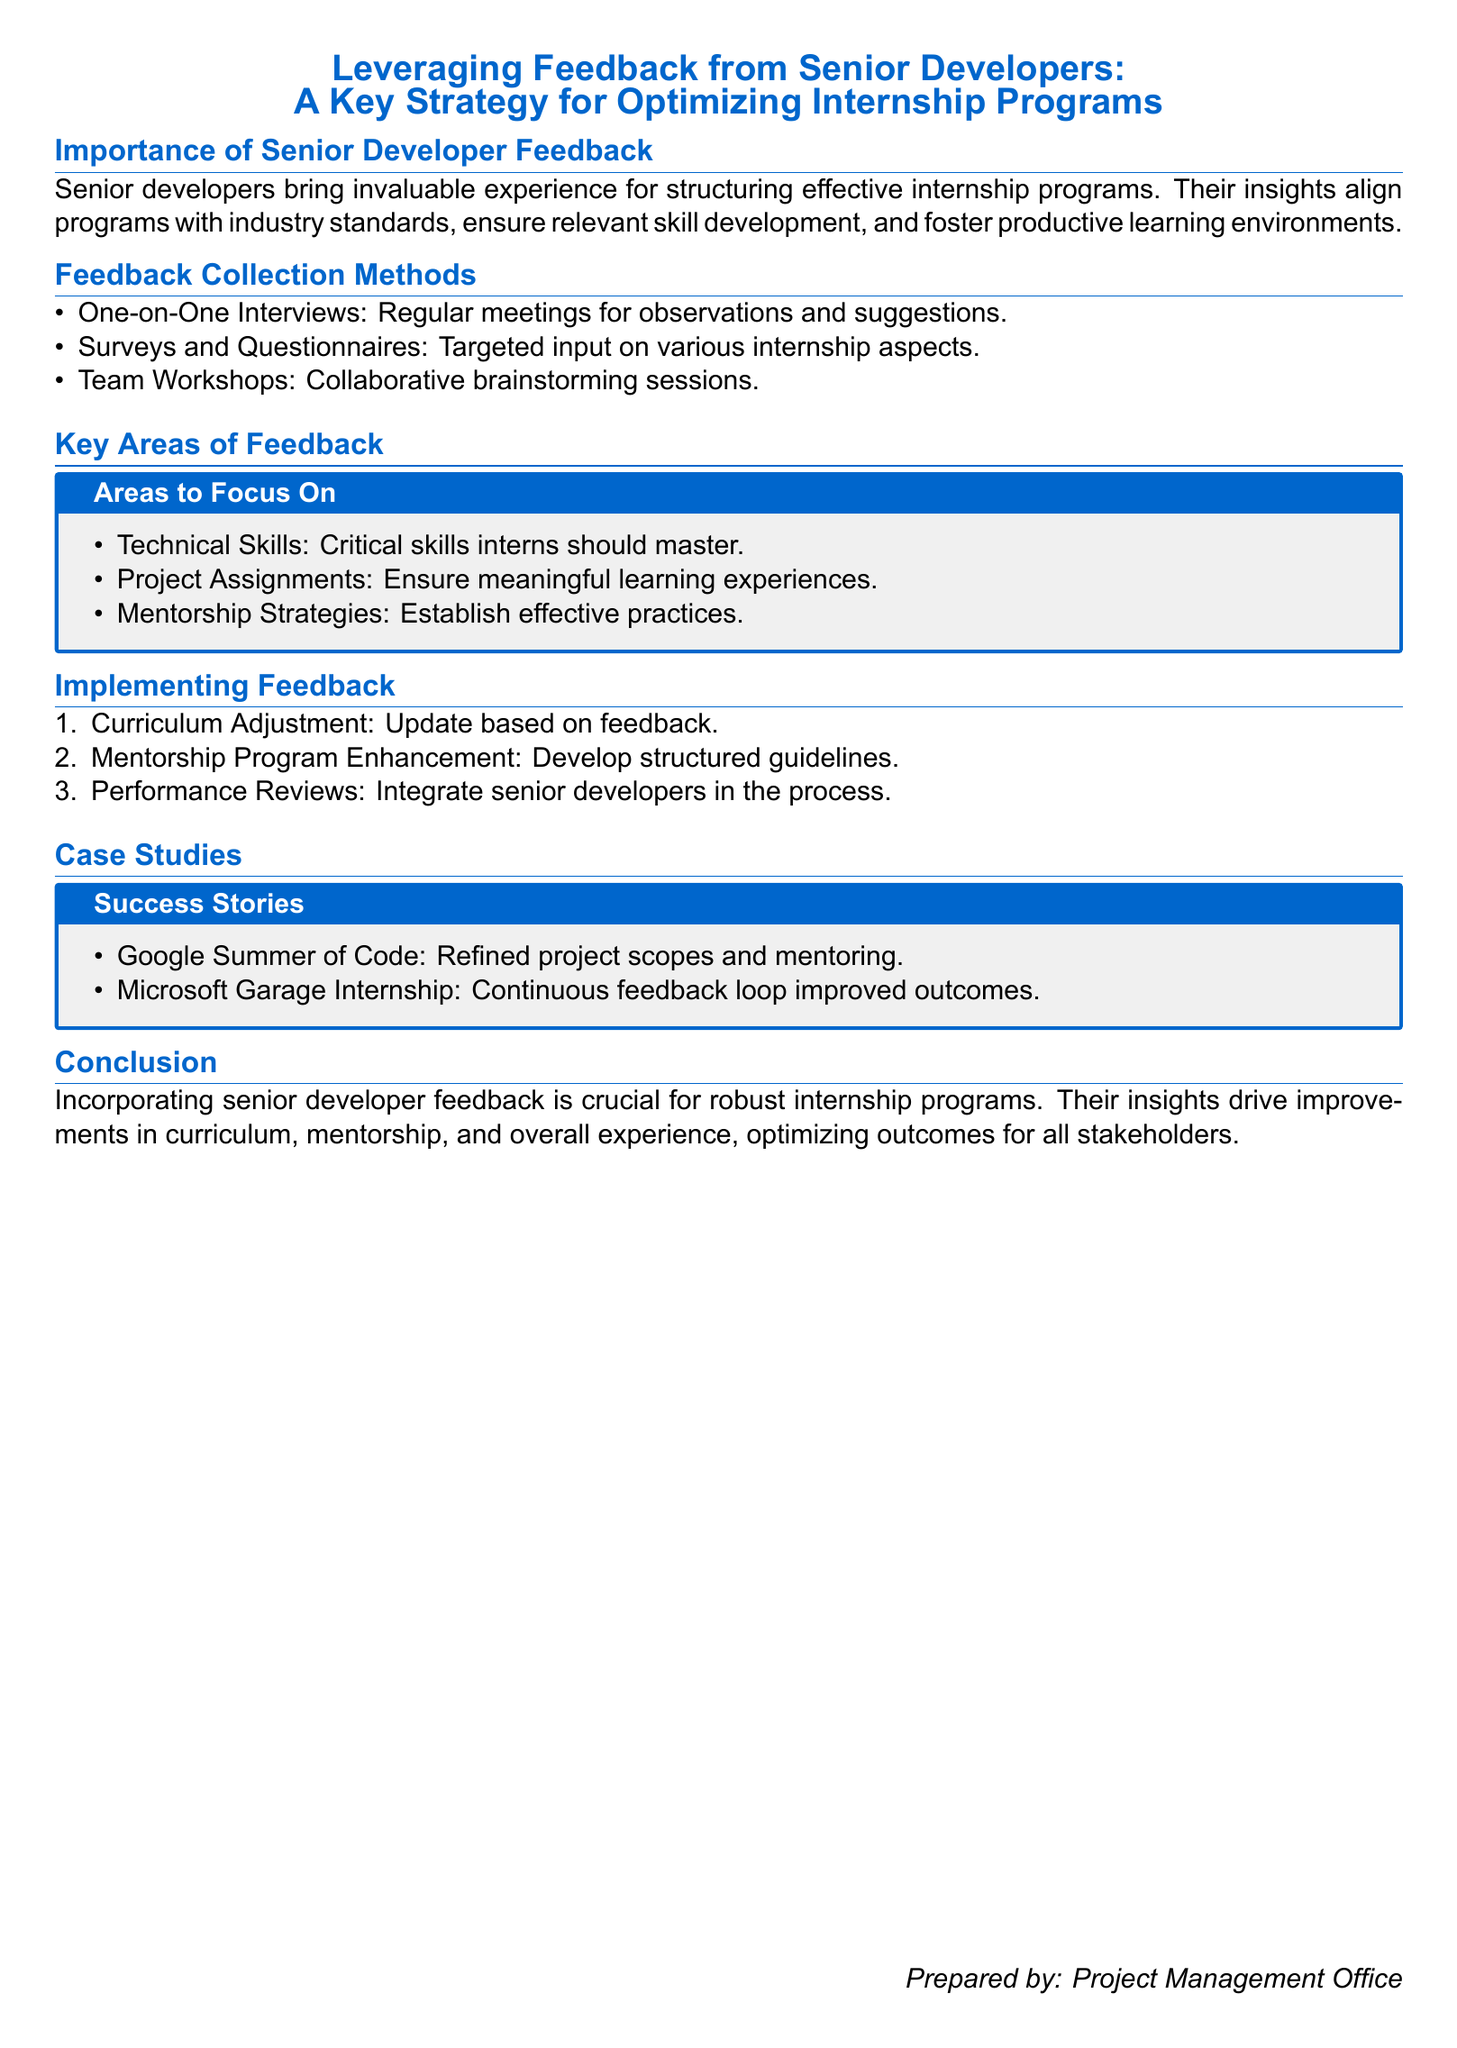What is the title of the document? The title is prominently displayed at the beginning of the document as the main theme.
Answer: Leveraging Feedback from Senior Developers: A Key Strategy for Optimizing Internship Programs Who prepares the document? The document credits a specific office for its preparation, indicating the responsible entity.
Answer: Project Management Office What is one method of feedback collection mentioned? The document lists various methods for collecting feedback from senior developers.
Answer: One-on-One Interviews How many key areas of feedback are listed? The document specifies the number of areas to focus on regarding feedback in a structured format.
Answer: Three Give an example of a case study mentioned. The document highlights specific examples of successful internship programs as case studies for reference.
Answer: Google Summer of Code What is the main conclusion of the document? The conclusion summarizes the overall message the document conveys about the importance of senior developer feedback.
Answer: Incorporating senior developer feedback is crucial for robust internship programs 